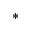<formula> <loc_0><loc_0><loc_500><loc_500>^ { * }</formula> 